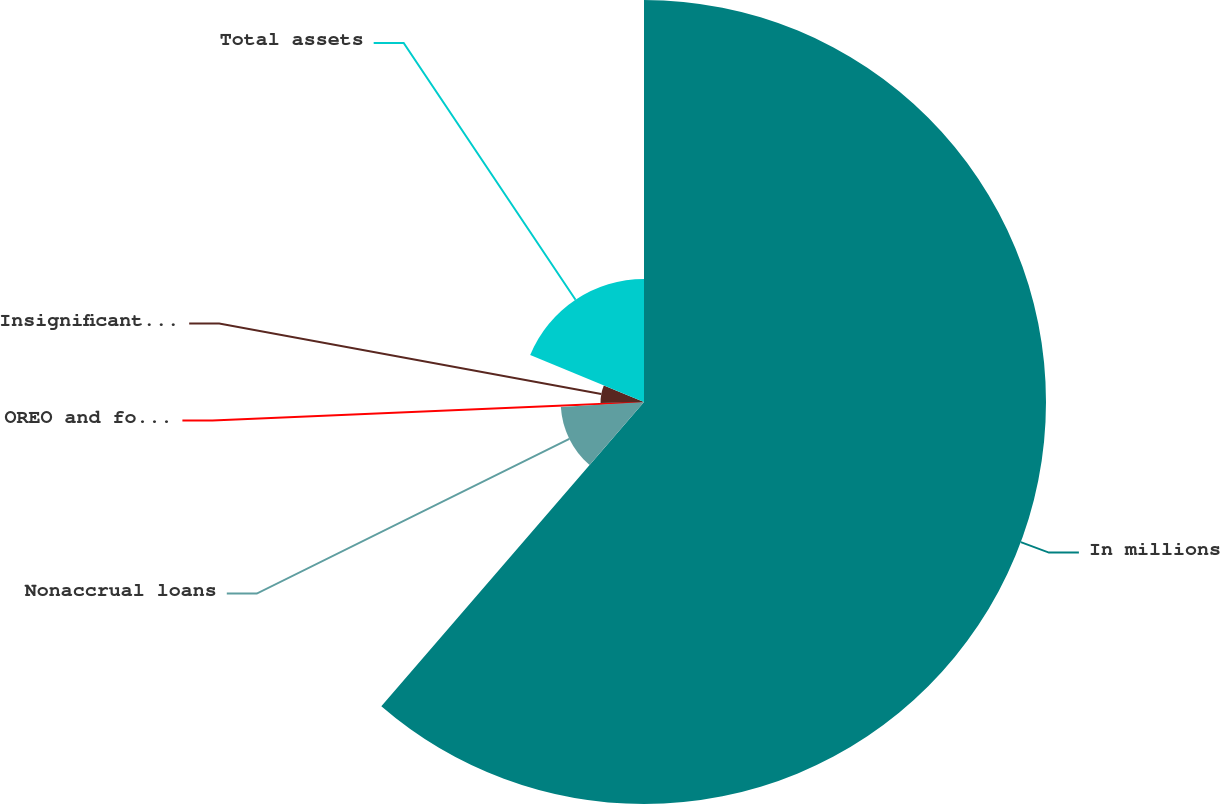<chart> <loc_0><loc_0><loc_500><loc_500><pie_chart><fcel>In millions<fcel>Nonaccrual loans<fcel>OREO and foreclosed assets<fcel>Insignificant assets<fcel>Total assets<nl><fcel>61.34%<fcel>12.71%<fcel>0.55%<fcel>6.63%<fcel>18.78%<nl></chart> 